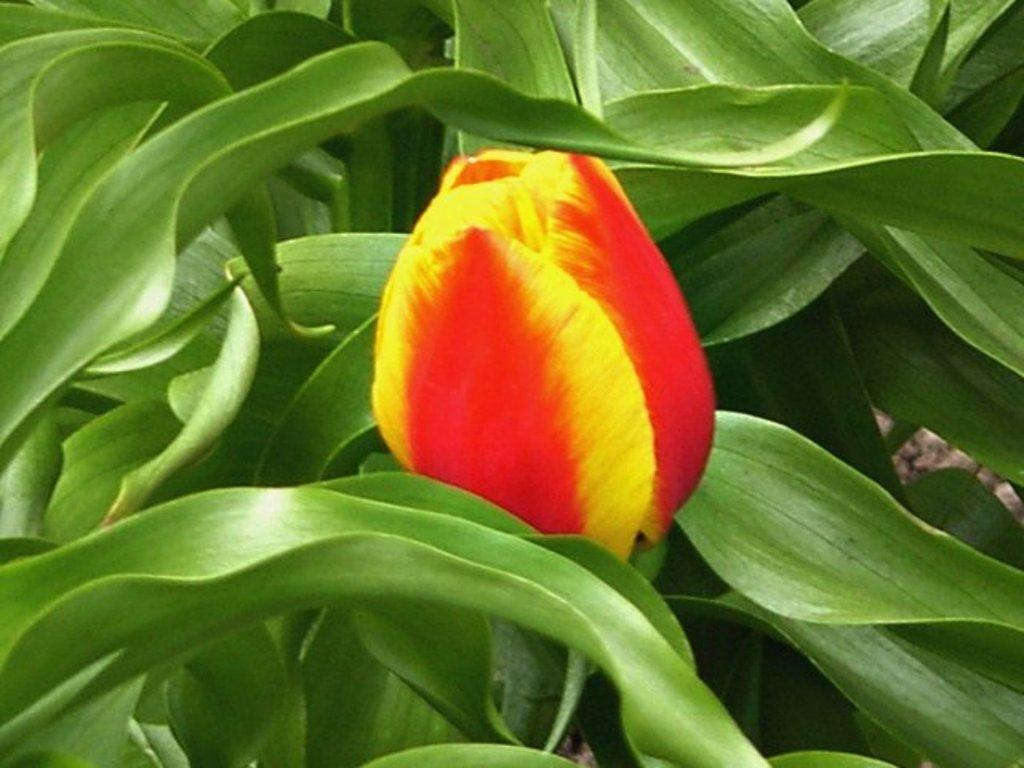What is the main subject of the image? There is a flower in the image. Where is the flower located? The flower is on a plant. What colors can be seen on the flower? The flower has red and yellow colors. What page of the story does the flower appear on? There is no story or page present in the image; it is a photograph of a flower on a plant. 